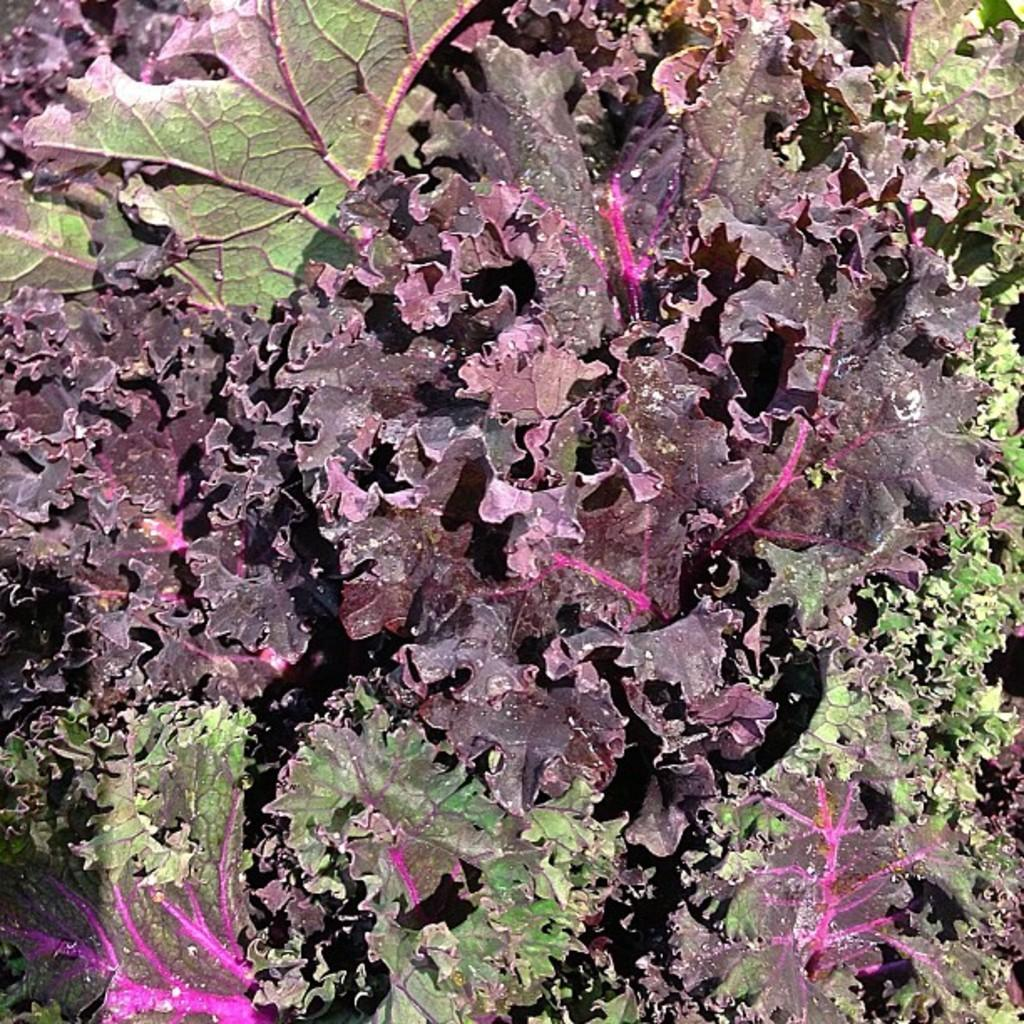What is the primary element visible in the image? The image is filled with leaves. What type of vegetation might the leaves belong to? The leaves could belong to trees, plants, or other vegetation. What season might the image represent, based on the presence of leaves? The image might represent a season with abundant foliage, such as spring or summer. What type of lunch is being served on the linen tablecloth in the image? There is no lunch or linen tablecloth present in the image; it is filled with leaves. 